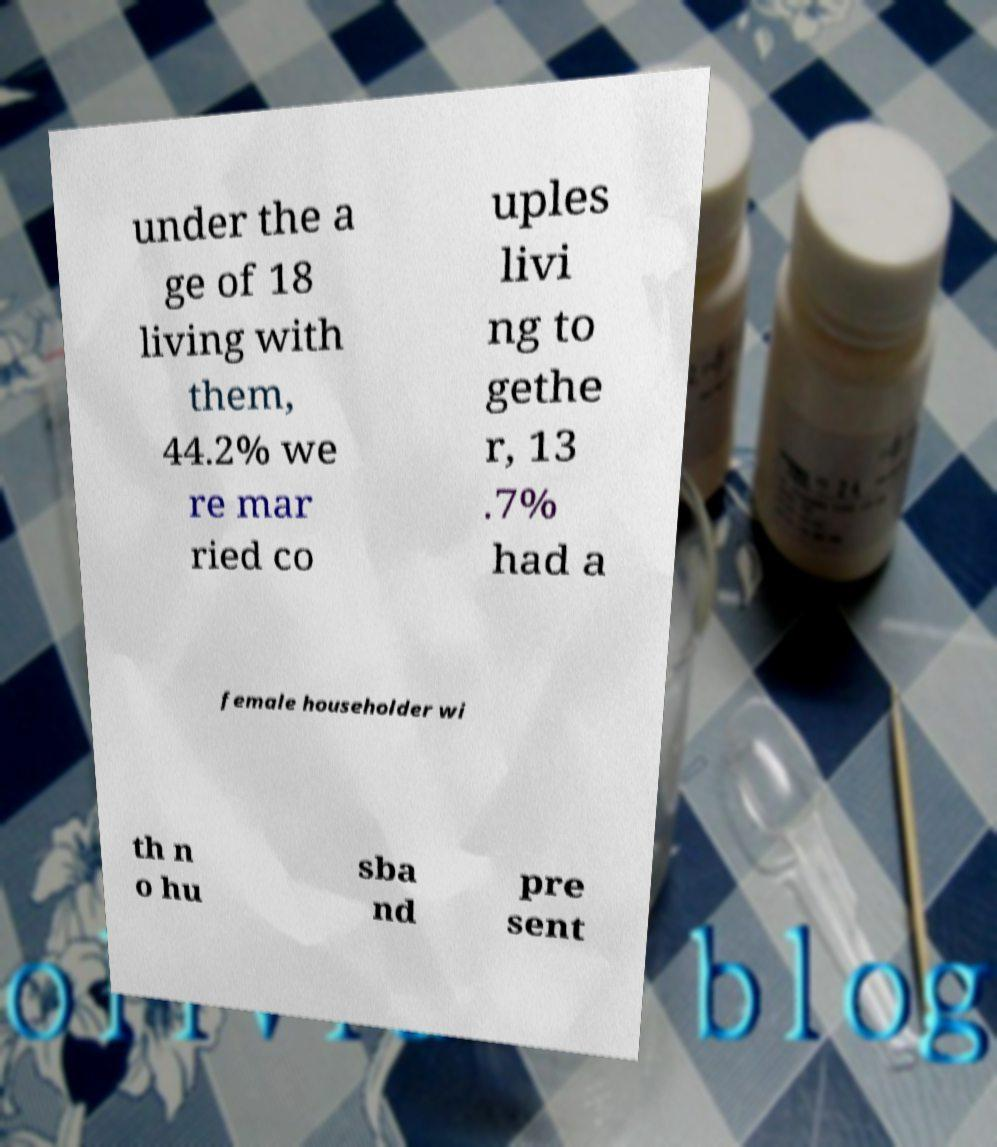Can you read and provide the text displayed in the image?This photo seems to have some interesting text. Can you extract and type it out for me? under the a ge of 18 living with them, 44.2% we re mar ried co uples livi ng to gethe r, 13 .7% had a female householder wi th n o hu sba nd pre sent 